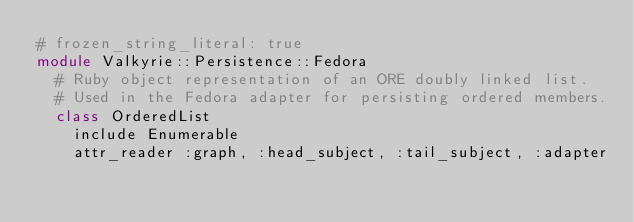Convert code to text. <code><loc_0><loc_0><loc_500><loc_500><_Ruby_># frozen_string_literal: true
module Valkyrie::Persistence::Fedora
  # Ruby object representation of an ORE doubly linked list.
  # Used in the Fedora adapter for persisting ordered members.
  class OrderedList
    include Enumerable
    attr_reader :graph, :head_subject, :tail_subject, :adapter</code> 